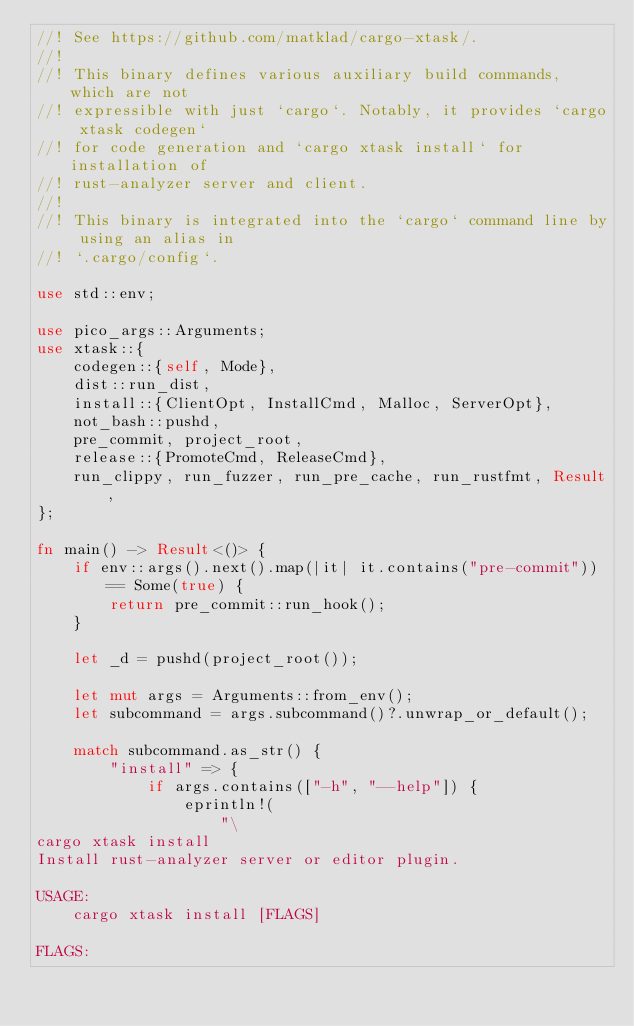<code> <loc_0><loc_0><loc_500><loc_500><_Rust_>//! See https://github.com/matklad/cargo-xtask/.
//!
//! This binary defines various auxiliary build commands, which are not
//! expressible with just `cargo`. Notably, it provides `cargo xtask codegen`
//! for code generation and `cargo xtask install` for installation of
//! rust-analyzer server and client.
//!
//! This binary is integrated into the `cargo` command line by using an alias in
//! `.cargo/config`.

use std::env;

use pico_args::Arguments;
use xtask::{
    codegen::{self, Mode},
    dist::run_dist,
    install::{ClientOpt, InstallCmd, Malloc, ServerOpt},
    not_bash::pushd,
    pre_commit, project_root,
    release::{PromoteCmd, ReleaseCmd},
    run_clippy, run_fuzzer, run_pre_cache, run_rustfmt, Result,
};

fn main() -> Result<()> {
    if env::args().next().map(|it| it.contains("pre-commit")) == Some(true) {
        return pre_commit::run_hook();
    }

    let _d = pushd(project_root());

    let mut args = Arguments::from_env();
    let subcommand = args.subcommand()?.unwrap_or_default();

    match subcommand.as_str() {
        "install" => {
            if args.contains(["-h", "--help"]) {
                eprintln!(
                    "\
cargo xtask install
Install rust-analyzer server or editor plugin.

USAGE:
    cargo xtask install [FLAGS]

FLAGS:</code> 